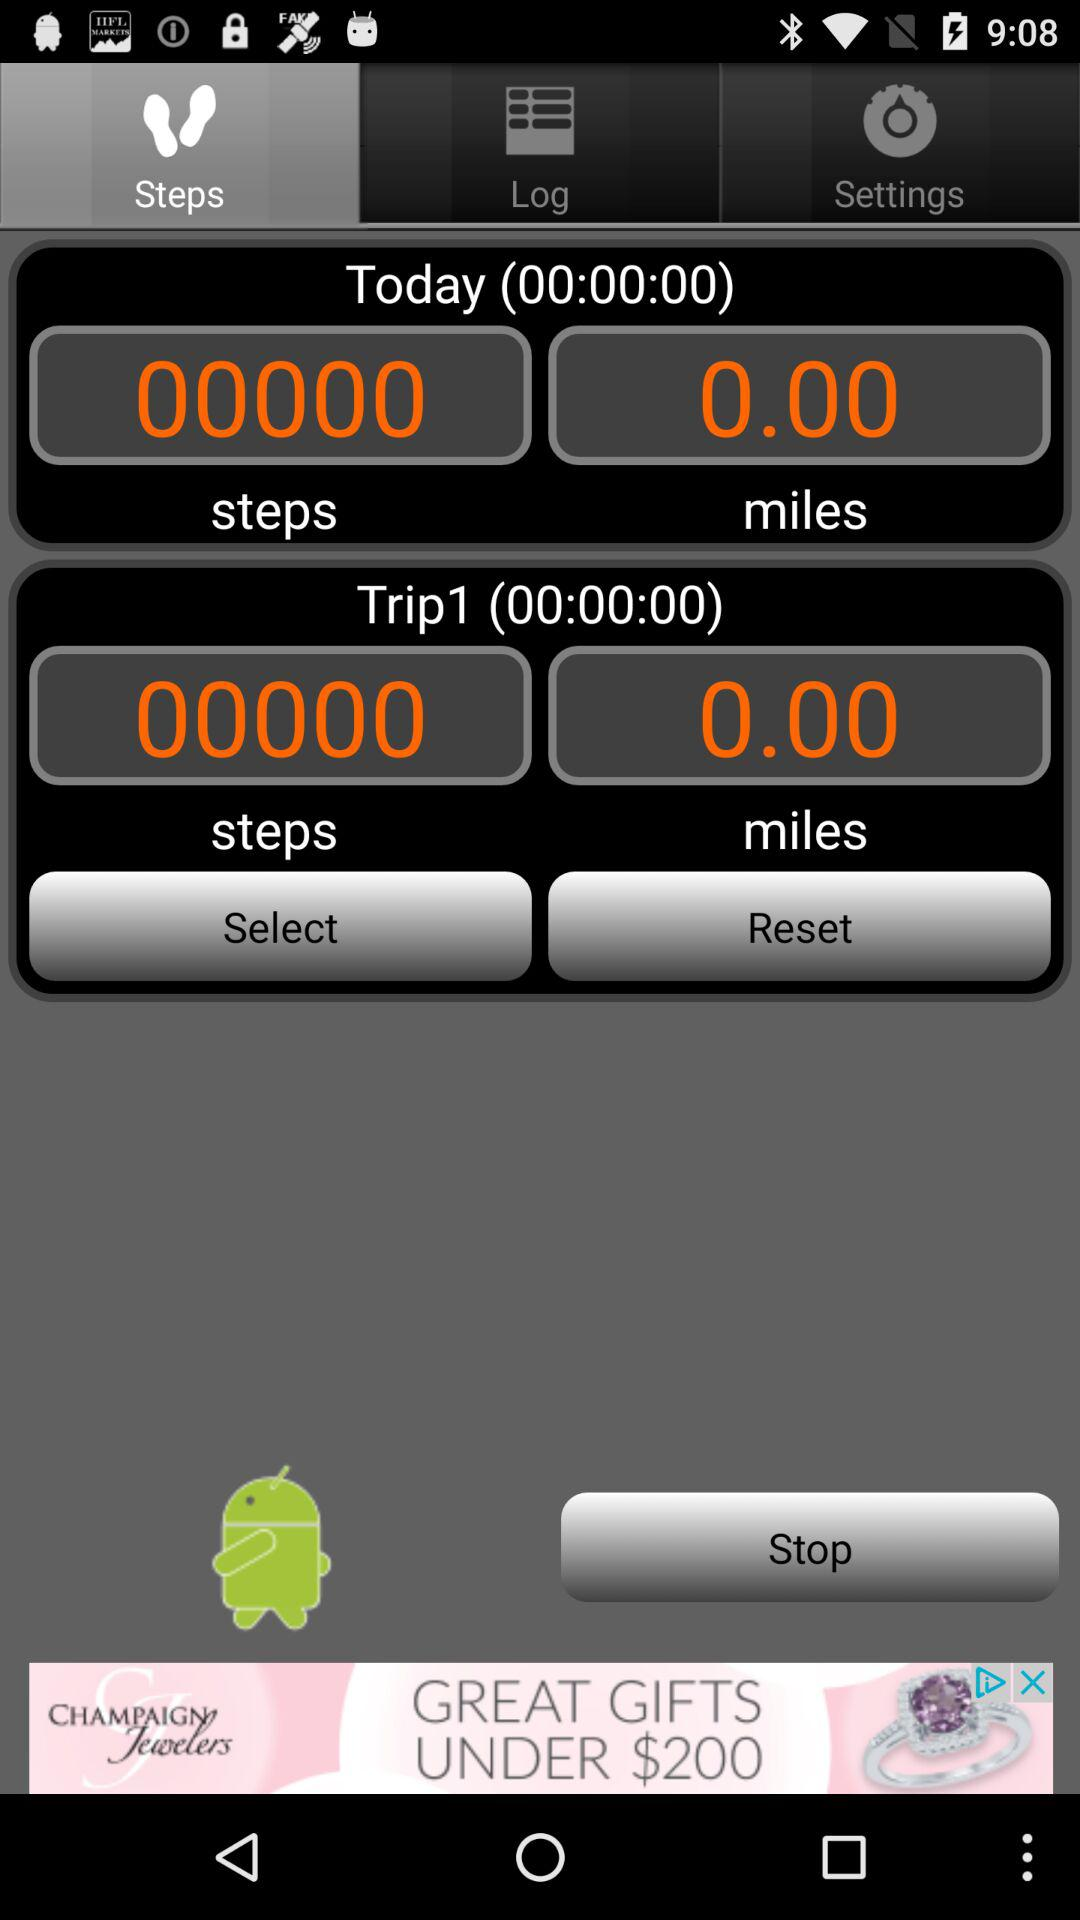How many miles on trip one? The miles on trip one are 0.00. 